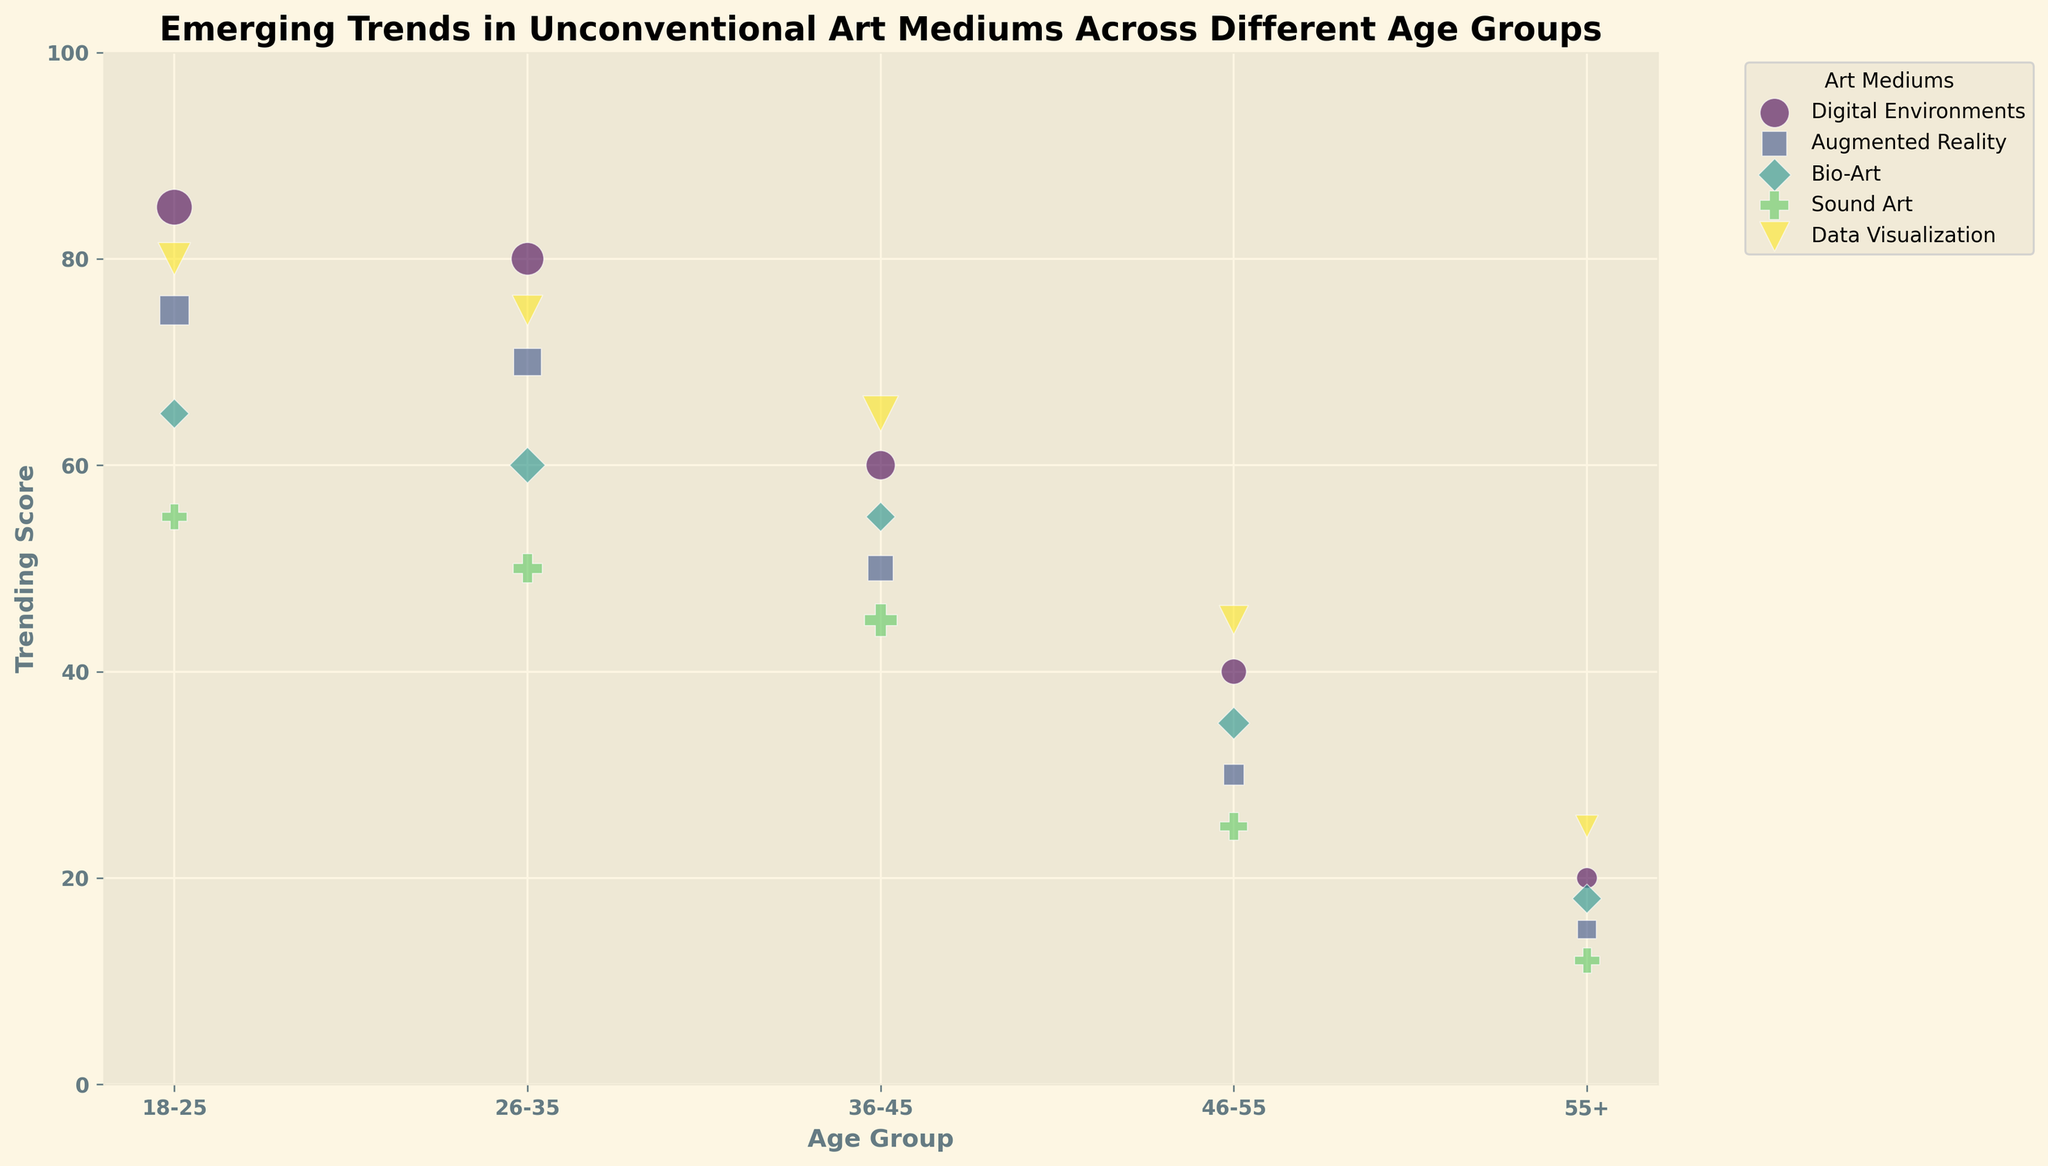What is the most popular art medium among 18-25 year-olds in terms of trending score? By observing the bubbles for the 18-25 age group, the one with the highest Y-axis value (trending score) represents the most popular medium. The bubble for Digital Environments has the highest trending score (85).
Answer: Digital Environments Which age group has the lowest trending score for Sound Art? Look at the bubbles corresponding to Sound Art across different age groups. The smallest Y-axis value for Sound Art is in the 55+ age group, with a score of 12.
Answer: 55+ How does the percentage of artists in 26-35 year-olds creating Data Visualization compare to those in 36-45 year-olds? Find the size of the bubbles representing Data Visualization for these age groups. The 26-35 group has a bubble size of 22, and the 36-45 group has a bubble size of 30. Percentage is higher in 36-45 year-olds.
Answer: Higher in 36-45 year-olds What is the aggregated trending score of Bio-Art across all age groups? Sum the Y-axis values for Bio-Art across all age groups (65 + 60 + 55 + 35 + 18) to get the total. 65 + 60 + 55 + 35 + 18 = 233
Answer: 233 Which art medium is least popular among the 46-55 age group based on trending score? Check the bubbles for the 46-55 age group and identify the one with the lowest Y-axis value. Augmented Reality has a score of 30, which is the lowest among the art mediums.
Answer: Augmented Reality What is the difference in the trending score between Digital Environments in the 18-25 age group and the 46-55 age group? Subtract the trending score of Digital Environments for the 46-55 group from the 18-25 group (85 - 40 = 45).
Answer: 45 How does the popularity (percentage of artists) of Data Visualization compare between 18-25 and 55+ age groups? Compare the size of the bubbles for Data Visualization in these age groups. The 18-25 group has a size of 25, while the 55+ group has a size of 12. It is more popular in the 18-25 age group.
Answer: More popular in 18-25 Which age group shows the highest trending score for Data Visualization? Identify the bubble for Data Visualization with the highest Y-axis value. The 18-25 age group has the highest score of 80.
Answer: 18-25 What is the average trending score for Augmented Reality across all age groups? Sum the trending scores of Augmented Reality (75 + 70 + 50 + 30 + 15) and divide by the number of age groups (5). (75 + 70 + 50 + 30 + 15) / 5 = 48
Answer: 48 